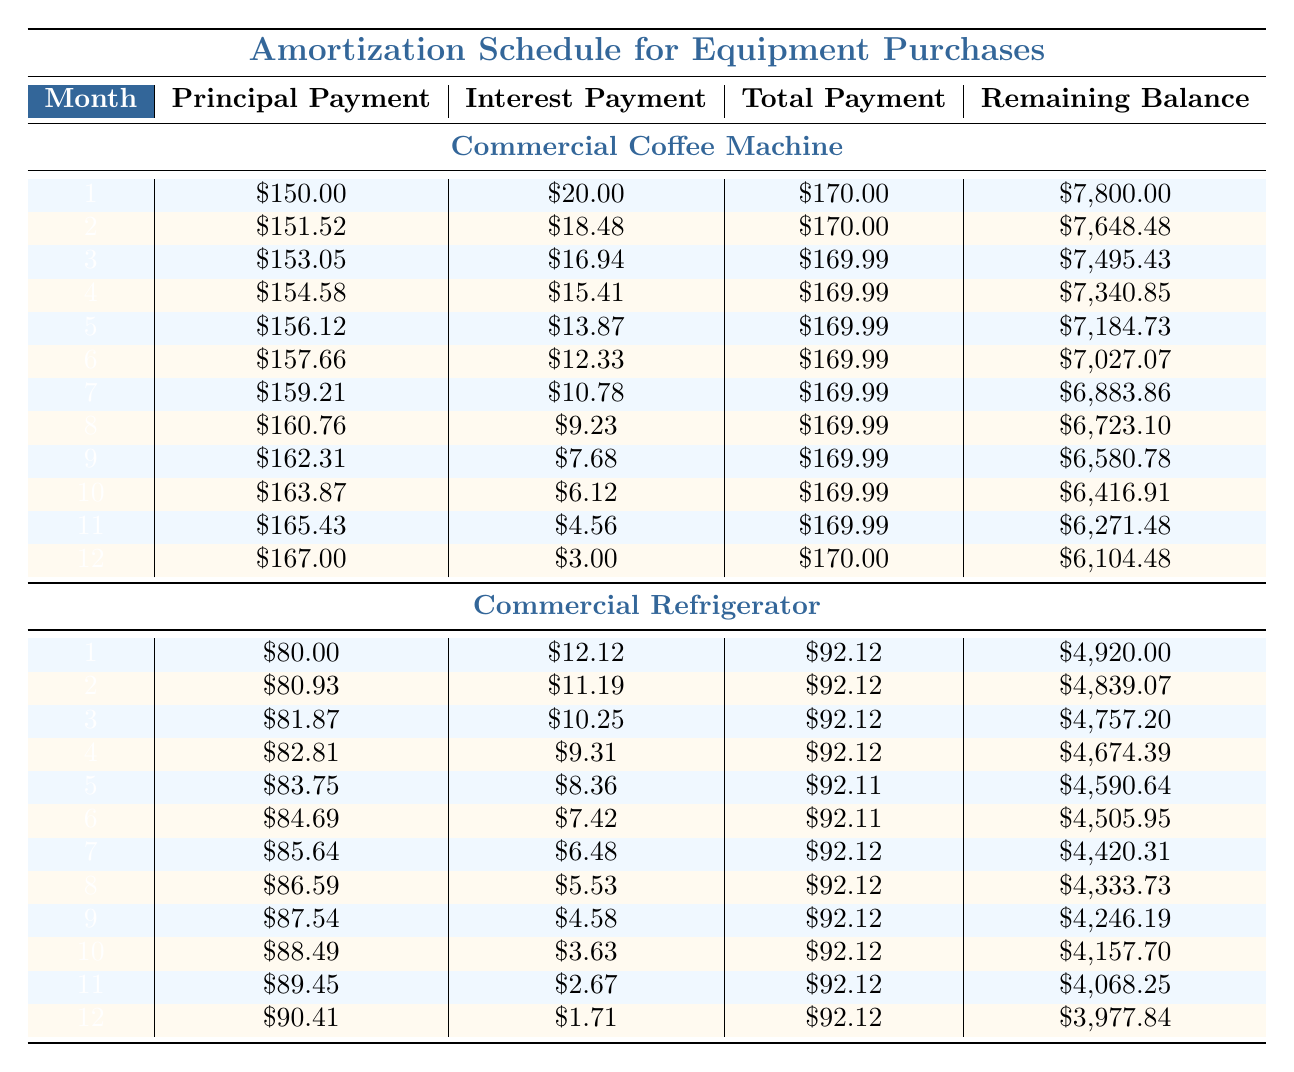What is the principal payment in the first month for the Commercial Coffee Machine? The table shows that the principal payment for the first month of the Commercial Coffee Machine is listed under the corresponding row, which states it is 150.00.
Answer: 150.00 How much is the total payment for the Commercial Refrigerator in month 5? The total payment for the Commercial Refrigerator in month 5 can be found in the table, specifically in the 5th row for this item, which indicates it is 92.11.
Answer: 92.11 What is the total amount of principal payments made for the Commercial Coffee Machine in the first four months? To calculate this, we need to sum the principal payments from the first four months: 150.00 + 151.52 + 153.05 + 154.58 = 609.15.
Answer: 609.15 Is the total payment for the Commercial Refrigerator different in the first and last month? Looking at the table, the total payment for the first month is 92.12, while in the last month it is 92.12 as well. Since they are equal, the answer is no.
Answer: No What is the remaining balance after 12 months for the Commercial Coffee Machine? The table provides the remaining balance after 12 months for the Commercial Coffee Machine, which is shown as 6,104.48.
Answer: 6,104.48 How much interest payment was made in month 6 for the Commercial Coffee Machine? To find this, we look at the table under the 6th month row for the Commercial Coffee Machine, which indicates the interest payment is 12.33.
Answer: 12.33 What is the average monthly principal payment for the Commercial Refrigerator over the first 12 months? The total principal payments for the Commercial Refrigerator over the first 12 months can be calculated by summing each month's principal payment: 80.00 + 80.93 + 81.87 + 82.81 + 83.75 + 84.69 + 85.64 + 86.59 + 87.54 + 88.49 + 89.45 + 90.41 = 1,061.68. Dividing this by 12 gives an average of 88.47.
Answer: 88.47 What is the interest payment in month 10 for the Commercial Refrigerator? The table shows the interest payment listed for month 10 in the row for the Commercial Refrigerator, which is 3.63.
Answer: 3.63 Which equipment had a higher total payment in the first month, the Commercial Coffee Machine or the Commercial Refrigerator? The total payment for the Commercial Coffee Machine in the first month is 170.00, whereas for the Commercial Refrigerator, it is 92.12. Comparing these values shows that the Commercial Coffee Machine had the higher total payment.
Answer: Commercial Coffee Machine 